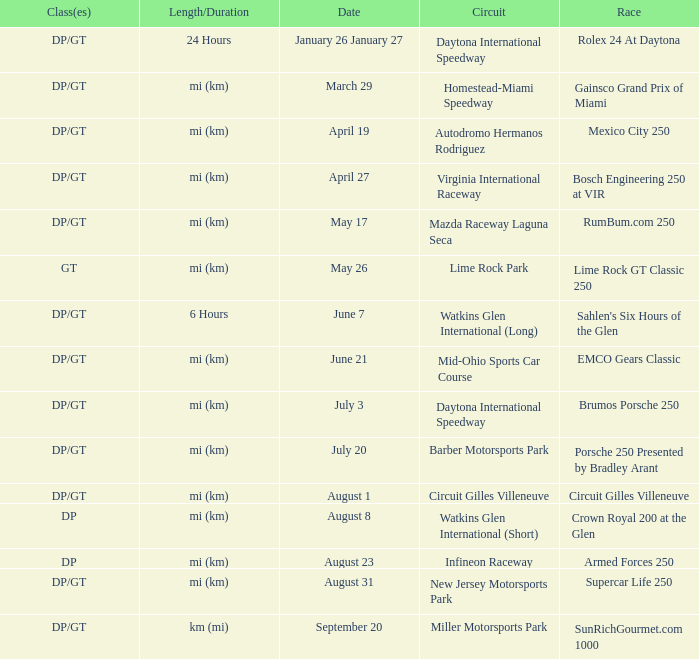What are the classes for the circuit that has the Mazda Raceway Laguna Seca race. DP/GT. 